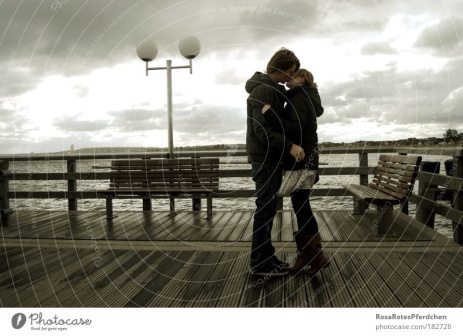This image looks serene. Could you write a poem inspired by it? Upon this weathered pier we stand,
Under a sky of muted grey,
Hand in hand, we face the wind,
As the world slips silently away.

In our embrace, the echoes blend,
Of times long past, of dreams unfurled,
Here we find our peace again,
In the soft whispers of a solemn world.

No words are needed in this place,
Where hearts speak louder than the sea,
Amidst the stillness, face to face,
We find our love eternally. That's beautiful. Now, what if there's a hidden treasure story related to this pier? Legend has it that a pirate's treasure lies buried somewhere near this pier. Every few decades, on a day just like this, under an overcast sky, the clues to its location become apparent to those who know where to look. The couple in the photograph could be modern-day adventurers, entwined not just in love but also in the thrilling quest of piecing together a centuries-old map they've discovered, leading them to the lost gold that could change their lives forever. 